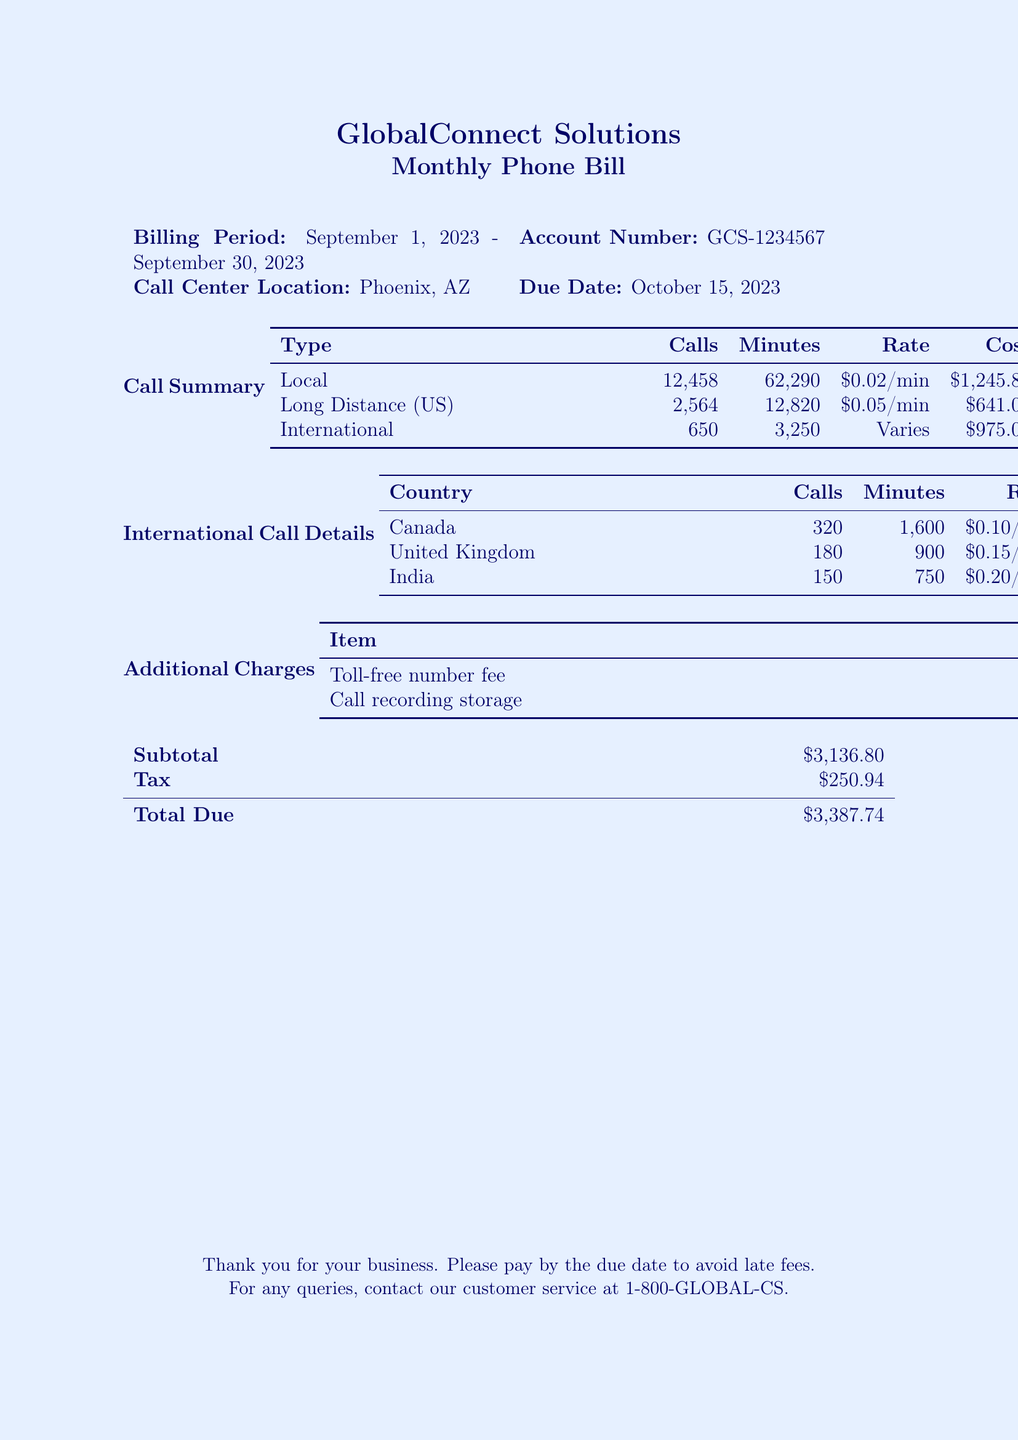what is the billing period? The billing period specified in the document is from September 1, 2023, to September 30, 2023.
Answer: September 1, 2023 - September 30, 2023 how many international calls were made? The number of international calls is listed in the call summary under the type 'International'.
Answer: 650 what is the rate for long-distance calls? The rate for long-distance calls is provided in the call summary for that specific type.
Answer: $0.05/min what is the total due amount? The total due amount is calculated by adding the subtotal and tax from the document.
Answer: $3,387.74 how many minutes were spent on local calls? The total minutes spent on local calls is detailed in the call summary.
Answer: 62,290 what is the cost of the calls made to Canada? The cost for calls made to Canada can be found in the international call details section.
Answer: $160.00 what is the subtotal before tax? The subtotal is presented in the billing summary and does not include tax.
Answer: $3,136.80 what additional charge is associated with call recording storage? The cost related to call recording storage is listed under additional charges in the document.
Answer: $75.00 which country had the highest number of international calls? The country with the highest number of international calls is indicated in the international call details section.
Answer: Canada 